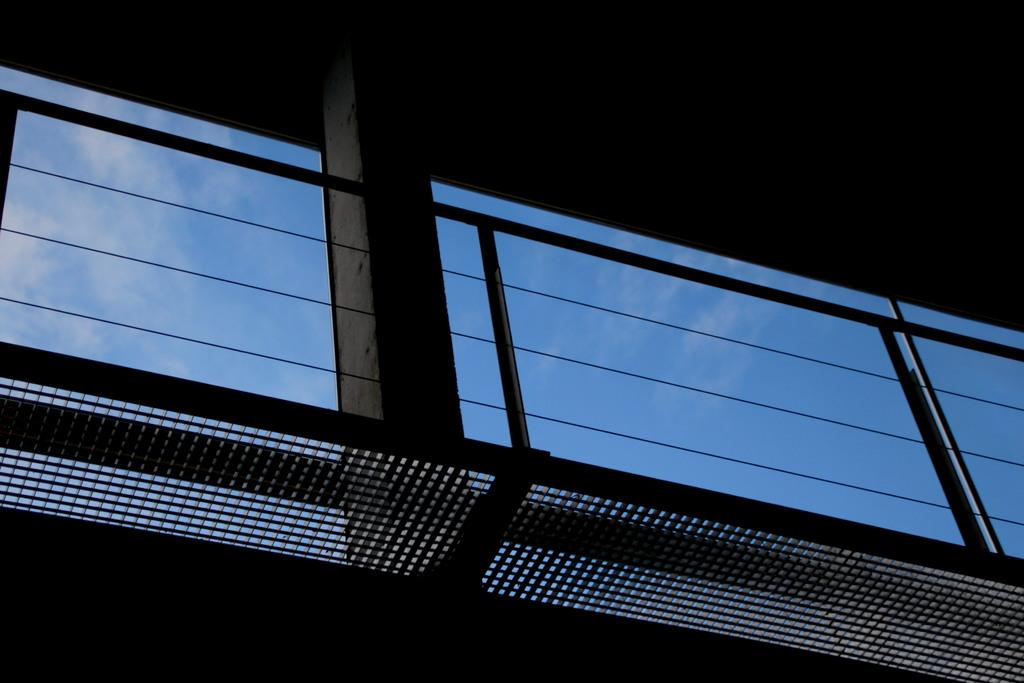What is the main structure visible in the image? There is a pillar in the image. What else can be seen in the image besides the pillar? There are wires in the image. What is visible in the background of the image? The sky is visible in the background of the image. How many people are participating in the camp shown in the image? There is no camp or people present in the image; it features a pillar and wires. What type of mass is being held in the image? There is no mass or gathering of people present in the image; it features a pillar and wires. 